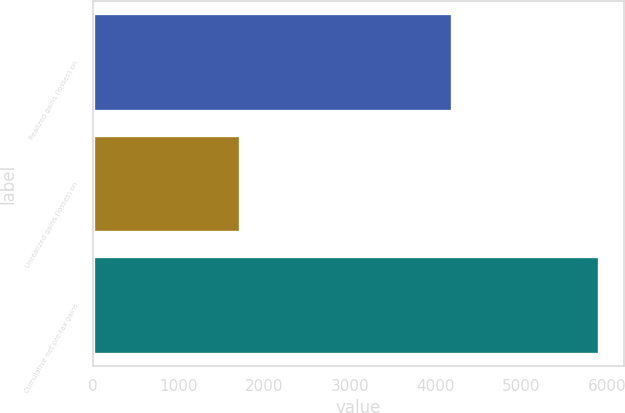Convert chart to OTSL. <chart><loc_0><loc_0><loc_500><loc_500><bar_chart><fcel>Realized gains (losses) on<fcel>Unrealized gains (losses) on<fcel>Cumulative net pre-tax gains<nl><fcel>4186<fcel>1716<fcel>5902<nl></chart> 